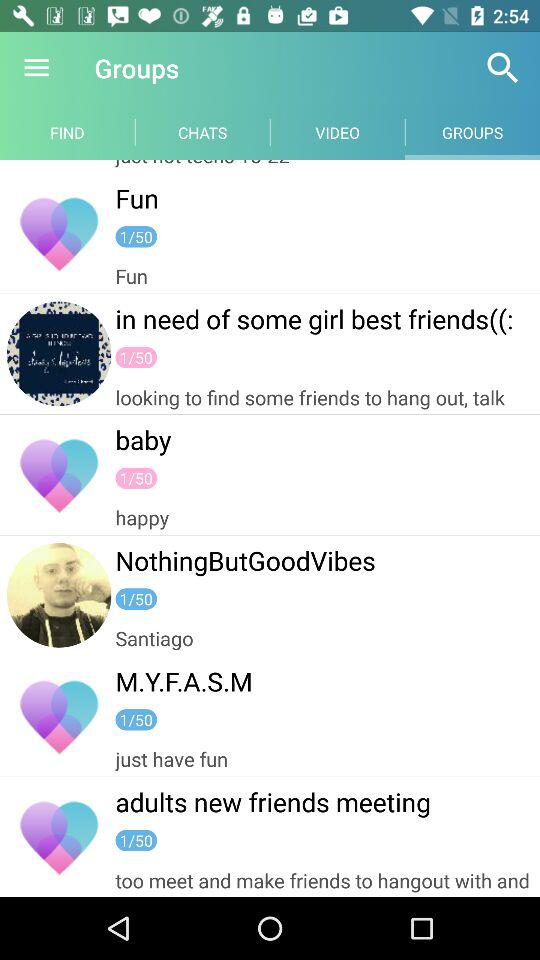How many members are there in "NothingButGoodVibes"? There is 1 member in "NothingButGoodVibes". 